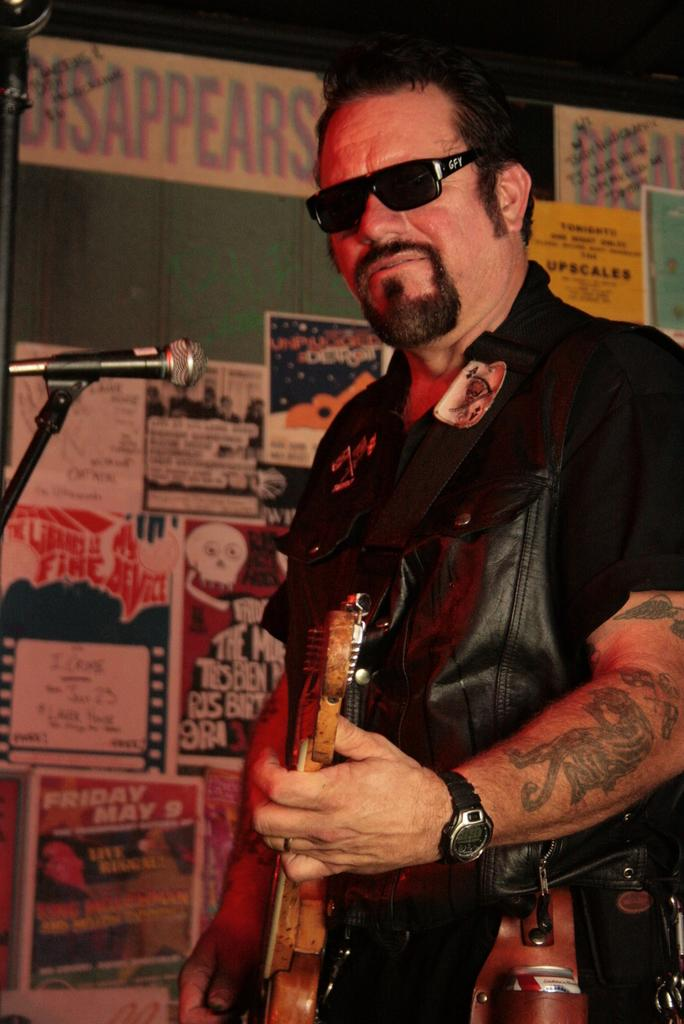What is the person in the image doing? The person is playing a guitar. What type of clothing is the person wearing? The person is wearing a black jacket. What protective gear is the person wearing? The person is wearing goggles. What accessory is the person wearing on their wrist? The person is wearing a wristwatch. What equipment is in front of the person? There is a microphone in front of the person. How many cats are sitting on the bike in the image? There is no bike or cats present in the image. 